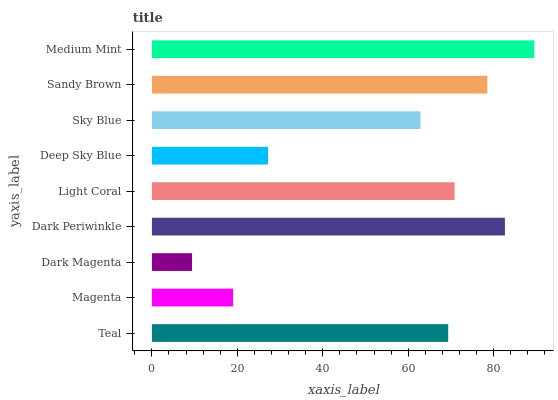Is Dark Magenta the minimum?
Answer yes or no. Yes. Is Medium Mint the maximum?
Answer yes or no. Yes. Is Magenta the minimum?
Answer yes or no. No. Is Magenta the maximum?
Answer yes or no. No. Is Teal greater than Magenta?
Answer yes or no. Yes. Is Magenta less than Teal?
Answer yes or no. Yes. Is Magenta greater than Teal?
Answer yes or no. No. Is Teal less than Magenta?
Answer yes or no. No. Is Teal the high median?
Answer yes or no. Yes. Is Teal the low median?
Answer yes or no. Yes. Is Medium Mint the high median?
Answer yes or no. No. Is Medium Mint the low median?
Answer yes or no. No. 